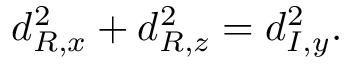<formula> <loc_0><loc_0><loc_500><loc_500>d _ { R , x } ^ { 2 } + d _ { R , z } ^ { 2 } = d _ { I , y } ^ { 2 } .</formula> 